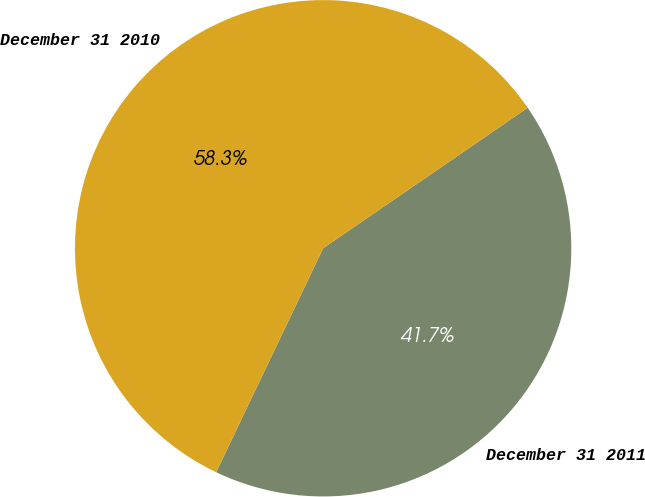Convert chart. <chart><loc_0><loc_0><loc_500><loc_500><pie_chart><fcel>December 31 2011<fcel>December 31 2010<nl><fcel>41.67%<fcel>58.33%<nl></chart> 